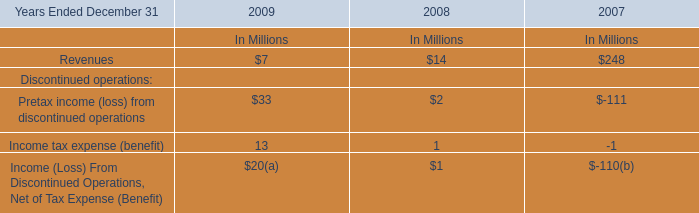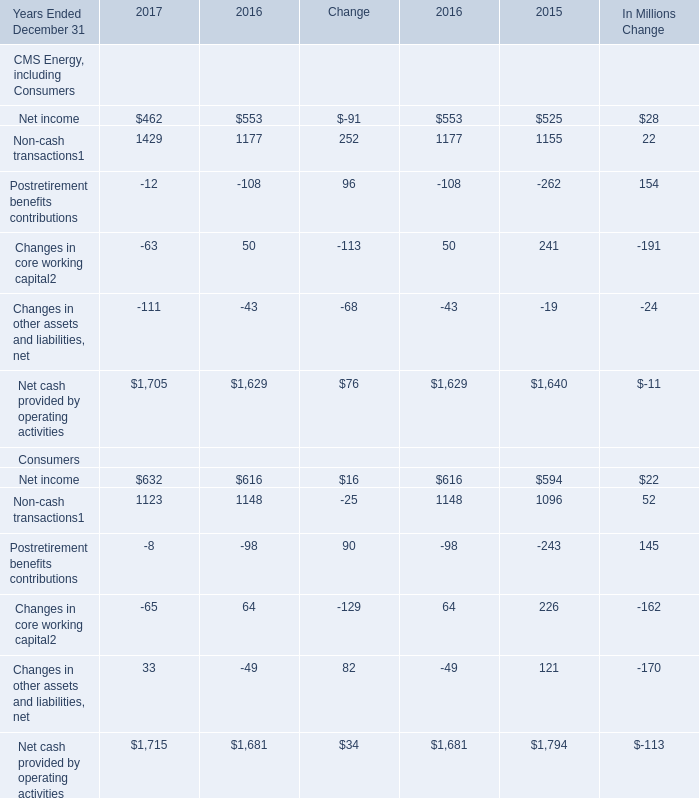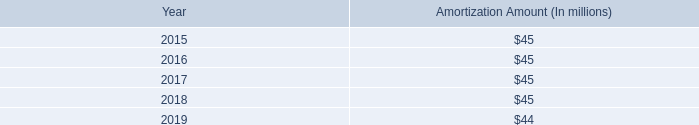What is the growing rate of Net income of CMS Energy, including Consumers in the year with the most Non-cash transactions of CMS Energy, including Consumers? 
Computations: ((462 - 553) / 553)
Answer: -0.16456. 